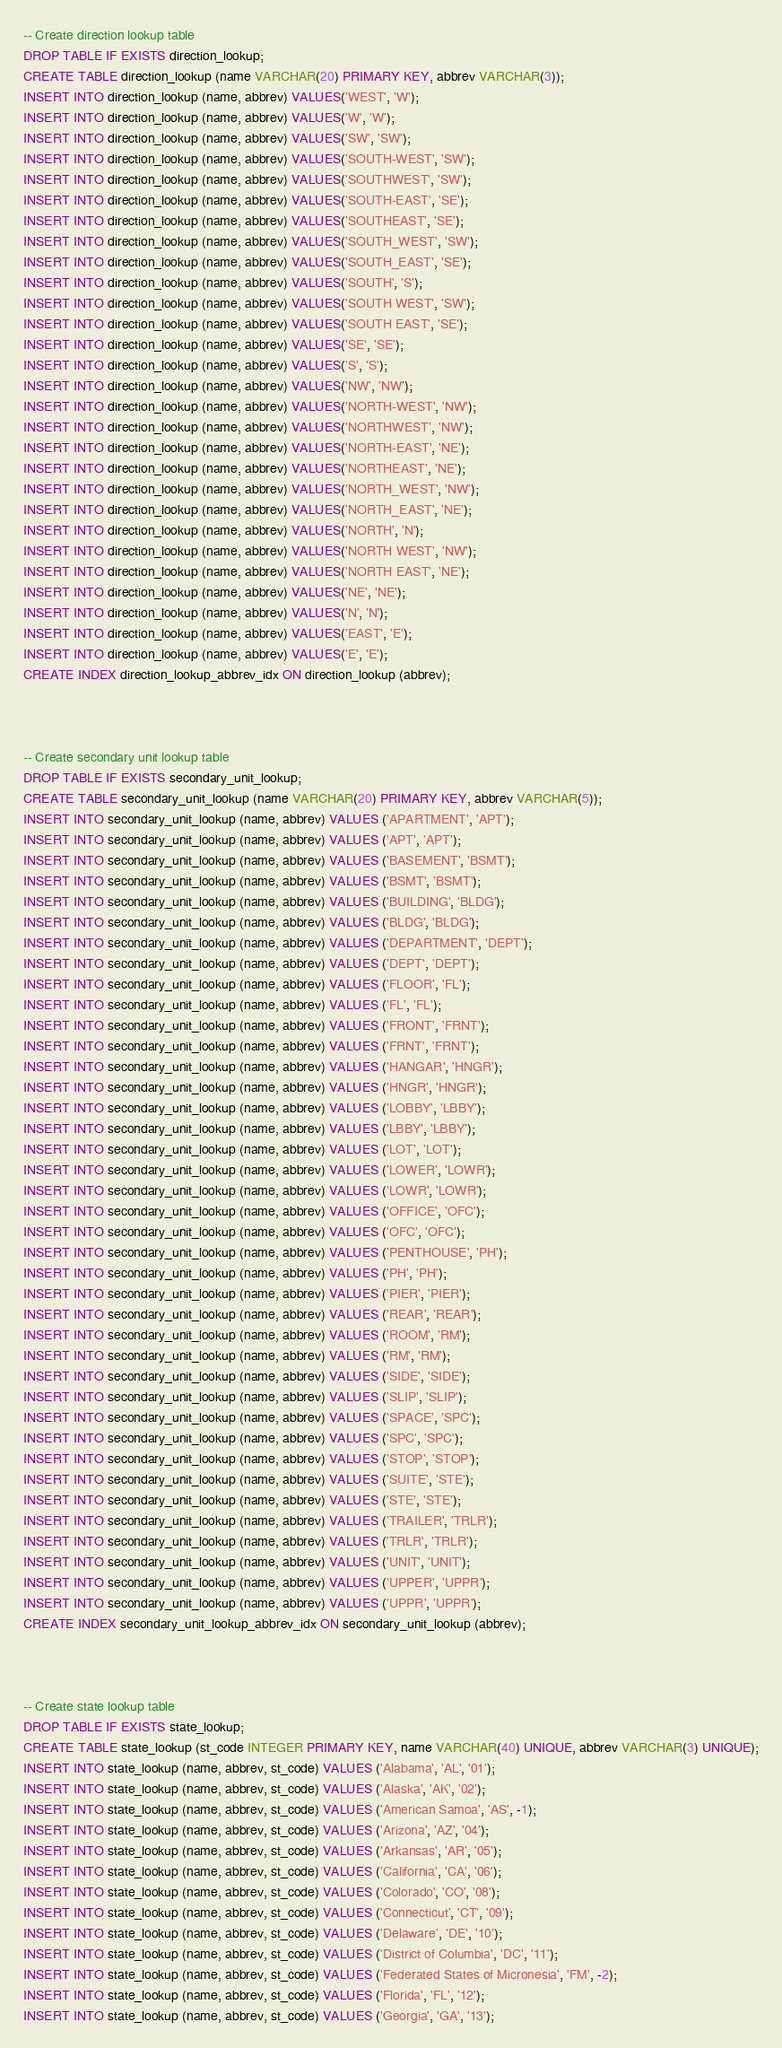Convert code to text. <code><loc_0><loc_0><loc_500><loc_500><_SQL_>-- Create direction lookup table
DROP TABLE IF EXISTS direction_lookup;
CREATE TABLE direction_lookup (name VARCHAR(20) PRIMARY KEY, abbrev VARCHAR(3));
INSERT INTO direction_lookup (name, abbrev) VALUES('WEST', 'W');
INSERT INTO direction_lookup (name, abbrev) VALUES('W', 'W');
INSERT INTO direction_lookup (name, abbrev) VALUES('SW', 'SW');
INSERT INTO direction_lookup (name, abbrev) VALUES('SOUTH-WEST', 'SW');
INSERT INTO direction_lookup (name, abbrev) VALUES('SOUTHWEST', 'SW');
INSERT INTO direction_lookup (name, abbrev) VALUES('SOUTH-EAST', 'SE');
INSERT INTO direction_lookup (name, abbrev) VALUES('SOUTHEAST', 'SE');
INSERT INTO direction_lookup (name, abbrev) VALUES('SOUTH_WEST', 'SW');
INSERT INTO direction_lookup (name, abbrev) VALUES('SOUTH_EAST', 'SE');
INSERT INTO direction_lookup (name, abbrev) VALUES('SOUTH', 'S');
INSERT INTO direction_lookup (name, abbrev) VALUES('SOUTH WEST', 'SW');
INSERT INTO direction_lookup (name, abbrev) VALUES('SOUTH EAST', 'SE');
INSERT INTO direction_lookup (name, abbrev) VALUES('SE', 'SE');
INSERT INTO direction_lookup (name, abbrev) VALUES('S', 'S');
INSERT INTO direction_lookup (name, abbrev) VALUES('NW', 'NW');
INSERT INTO direction_lookup (name, abbrev) VALUES('NORTH-WEST', 'NW');
INSERT INTO direction_lookup (name, abbrev) VALUES('NORTHWEST', 'NW');
INSERT INTO direction_lookup (name, abbrev) VALUES('NORTH-EAST', 'NE');
INSERT INTO direction_lookup (name, abbrev) VALUES('NORTHEAST', 'NE');
INSERT INTO direction_lookup (name, abbrev) VALUES('NORTH_WEST', 'NW');
INSERT INTO direction_lookup (name, abbrev) VALUES('NORTH_EAST', 'NE');
INSERT INTO direction_lookup (name, abbrev) VALUES('NORTH', 'N');
INSERT INTO direction_lookup (name, abbrev) VALUES('NORTH WEST', 'NW');
INSERT INTO direction_lookup (name, abbrev) VALUES('NORTH EAST', 'NE');
INSERT INTO direction_lookup (name, abbrev) VALUES('NE', 'NE');
INSERT INTO direction_lookup (name, abbrev) VALUES('N', 'N');
INSERT INTO direction_lookup (name, abbrev) VALUES('EAST', 'E');
INSERT INTO direction_lookup (name, abbrev) VALUES('E', 'E');
CREATE INDEX direction_lookup_abbrev_idx ON direction_lookup (abbrev);



-- Create secondary unit lookup table
DROP TABLE IF EXISTS secondary_unit_lookup;
CREATE TABLE secondary_unit_lookup (name VARCHAR(20) PRIMARY KEY, abbrev VARCHAR(5));
INSERT INTO secondary_unit_lookup (name, abbrev) VALUES ('APARTMENT', 'APT');
INSERT INTO secondary_unit_lookup (name, abbrev) VALUES ('APT', 'APT');
INSERT INTO secondary_unit_lookup (name, abbrev) VALUES ('BASEMENT', 'BSMT');
INSERT INTO secondary_unit_lookup (name, abbrev) VALUES ('BSMT', 'BSMT');
INSERT INTO secondary_unit_lookup (name, abbrev) VALUES ('BUILDING', 'BLDG');
INSERT INTO secondary_unit_lookup (name, abbrev) VALUES ('BLDG', 'BLDG');
INSERT INTO secondary_unit_lookup (name, abbrev) VALUES ('DEPARTMENT', 'DEPT');
INSERT INTO secondary_unit_lookup (name, abbrev) VALUES ('DEPT', 'DEPT');
INSERT INTO secondary_unit_lookup (name, abbrev) VALUES ('FLOOR', 'FL');
INSERT INTO secondary_unit_lookup (name, abbrev) VALUES ('FL', 'FL');
INSERT INTO secondary_unit_lookup (name, abbrev) VALUES ('FRONT', 'FRNT');
INSERT INTO secondary_unit_lookup (name, abbrev) VALUES ('FRNT', 'FRNT');
INSERT INTO secondary_unit_lookup (name, abbrev) VALUES ('HANGAR', 'HNGR');
INSERT INTO secondary_unit_lookup (name, abbrev) VALUES ('HNGR', 'HNGR');
INSERT INTO secondary_unit_lookup (name, abbrev) VALUES ('LOBBY', 'LBBY');
INSERT INTO secondary_unit_lookup (name, abbrev) VALUES ('LBBY', 'LBBY');
INSERT INTO secondary_unit_lookup (name, abbrev) VALUES ('LOT', 'LOT');
INSERT INTO secondary_unit_lookup (name, abbrev) VALUES ('LOWER', 'LOWR');
INSERT INTO secondary_unit_lookup (name, abbrev) VALUES ('LOWR', 'LOWR');
INSERT INTO secondary_unit_lookup (name, abbrev) VALUES ('OFFICE', 'OFC');
INSERT INTO secondary_unit_lookup (name, abbrev) VALUES ('OFC', 'OFC');
INSERT INTO secondary_unit_lookup (name, abbrev) VALUES ('PENTHOUSE', 'PH');
INSERT INTO secondary_unit_lookup (name, abbrev) VALUES ('PH', 'PH');
INSERT INTO secondary_unit_lookup (name, abbrev) VALUES ('PIER', 'PIER');
INSERT INTO secondary_unit_lookup (name, abbrev) VALUES ('REAR', 'REAR');
INSERT INTO secondary_unit_lookup (name, abbrev) VALUES ('ROOM', 'RM');
INSERT INTO secondary_unit_lookup (name, abbrev) VALUES ('RM', 'RM');
INSERT INTO secondary_unit_lookup (name, abbrev) VALUES ('SIDE', 'SIDE');
INSERT INTO secondary_unit_lookup (name, abbrev) VALUES ('SLIP', 'SLIP');
INSERT INTO secondary_unit_lookup (name, abbrev) VALUES ('SPACE', 'SPC');
INSERT INTO secondary_unit_lookup (name, abbrev) VALUES ('SPC', 'SPC');
INSERT INTO secondary_unit_lookup (name, abbrev) VALUES ('STOP', 'STOP');
INSERT INTO secondary_unit_lookup (name, abbrev) VALUES ('SUITE', 'STE');
INSERT INTO secondary_unit_lookup (name, abbrev) VALUES ('STE', 'STE');
INSERT INTO secondary_unit_lookup (name, abbrev) VALUES ('TRAILER', 'TRLR');
INSERT INTO secondary_unit_lookup (name, abbrev) VALUES ('TRLR', 'TRLR');
INSERT INTO secondary_unit_lookup (name, abbrev) VALUES ('UNIT', 'UNIT');
INSERT INTO secondary_unit_lookup (name, abbrev) VALUES ('UPPER', 'UPPR');
INSERT INTO secondary_unit_lookup (name, abbrev) VALUES ('UPPR', 'UPPR');
CREATE INDEX secondary_unit_lookup_abbrev_idx ON secondary_unit_lookup (abbrev);



-- Create state lookup table
DROP TABLE IF EXISTS state_lookup;
CREATE TABLE state_lookup (st_code INTEGER PRIMARY KEY, name VARCHAR(40) UNIQUE, abbrev VARCHAR(3) UNIQUE);
INSERT INTO state_lookup (name, abbrev, st_code) VALUES ('Alabama', 'AL', '01');
INSERT INTO state_lookup (name, abbrev, st_code) VALUES ('Alaska', 'AK', '02');
INSERT INTO state_lookup (name, abbrev, st_code) VALUES ('American Samoa', 'AS', -1);
INSERT INTO state_lookup (name, abbrev, st_code) VALUES ('Arizona', 'AZ', '04');
INSERT INTO state_lookup (name, abbrev, st_code) VALUES ('Arkansas', 'AR', '05');
INSERT INTO state_lookup (name, abbrev, st_code) VALUES ('California', 'CA', '06');
INSERT INTO state_lookup (name, abbrev, st_code) VALUES ('Colorado', 'CO', '08');
INSERT INTO state_lookup (name, abbrev, st_code) VALUES ('Connecticut', 'CT', '09');
INSERT INTO state_lookup (name, abbrev, st_code) VALUES ('Delaware', 'DE', '10');
INSERT INTO state_lookup (name, abbrev, st_code) VALUES ('District of Columbia', 'DC', '11');
INSERT INTO state_lookup (name, abbrev, st_code) VALUES ('Federated States of Micronesia', 'FM', -2);
INSERT INTO state_lookup (name, abbrev, st_code) VALUES ('Florida', 'FL', '12');
INSERT INTO state_lookup (name, abbrev, st_code) VALUES ('Georgia', 'GA', '13');</code> 